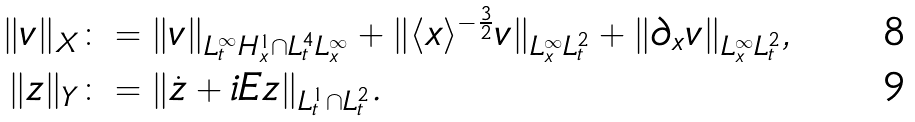<formula> <loc_0><loc_0><loc_500><loc_500>\| v \| _ { X } & \colon = \| v \| _ { L _ { t } ^ { \infty } H _ { x } ^ { 1 } \cap L _ { t } ^ { 4 } L _ { x } ^ { \infty } } + \| \langle x \rangle ^ { - \frac { 3 } { 2 } } v \| _ { L _ { x } ^ { \infty } L _ { t } ^ { 2 } } + \| \partial _ { x } v \| _ { L _ { x } ^ { \infty } L _ { t } ^ { 2 } } , \\ \| z \| _ { Y } & \colon = \| \dot { z } + i E z \| _ { L _ { t } ^ { 1 } \cap L _ { t } ^ { 2 } } .</formula> 